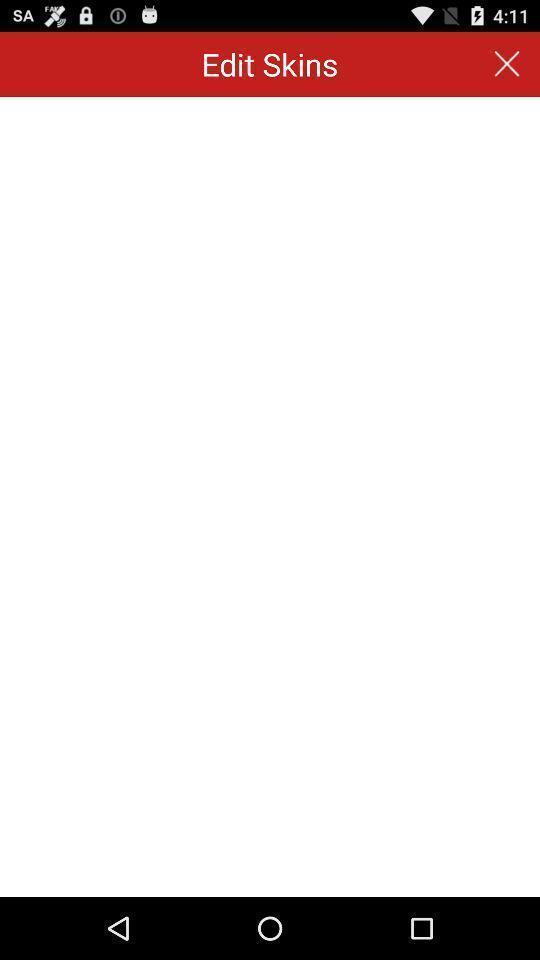Provide a detailed account of this screenshot. Screen displaying private diary app page. 